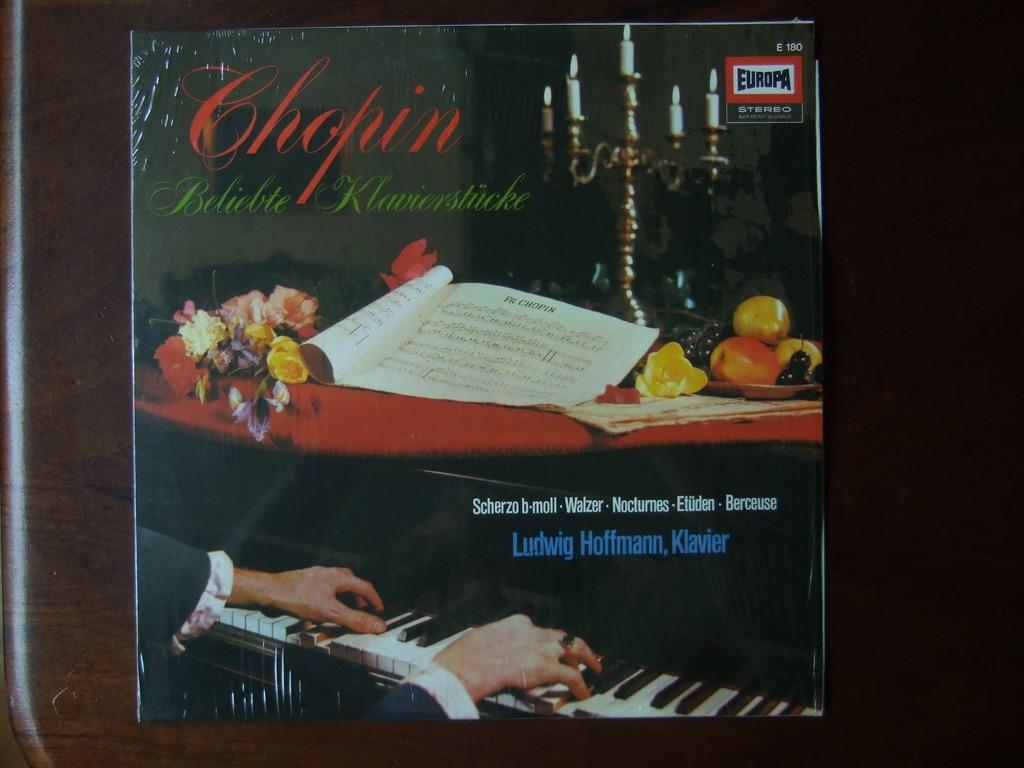What is on the wooden surface in the image? There is a paper on the wooden surface. What can be found on the paper? The paper contains text, images of flowers, fruits, a book, a table, candles, a piano, and a person's hands. Can you describe the images of flowers on the paper? The images of flowers on the paper are colorful and detailed. What is the purpose of the images of candles on the paper? The images of candles on the paper may be decorative or symbolic. How does the dirt on the person's hands help with the business in the image? There is no dirt or business present in the image; it only contains images of various objects and a person's hands. 